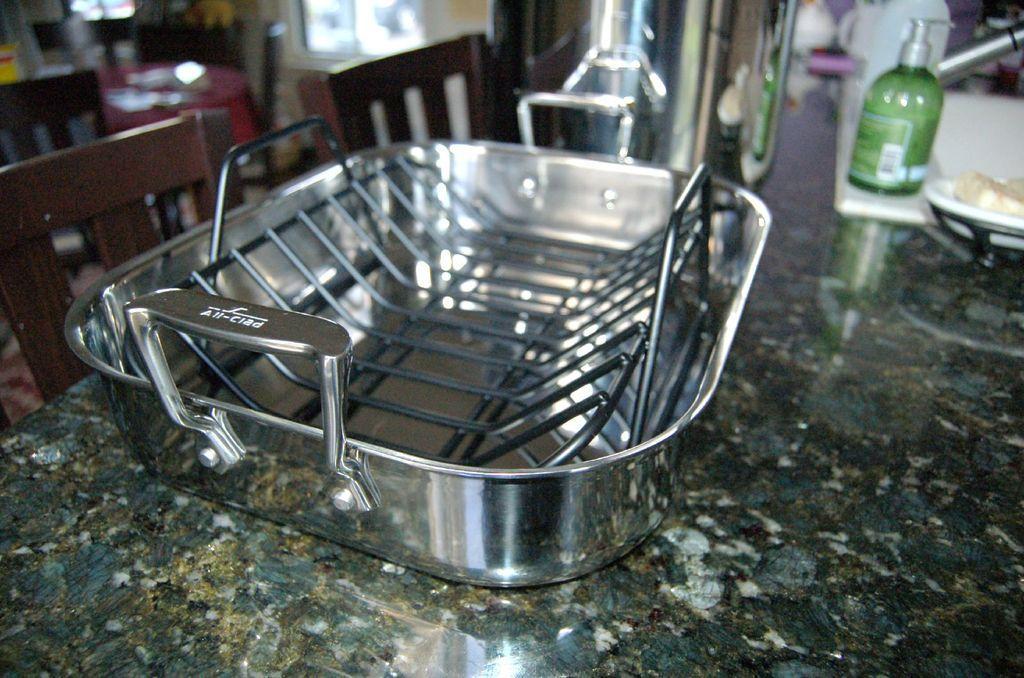Please provide a concise description of this image. there is a vessel on the table. at the left there are chairs. 